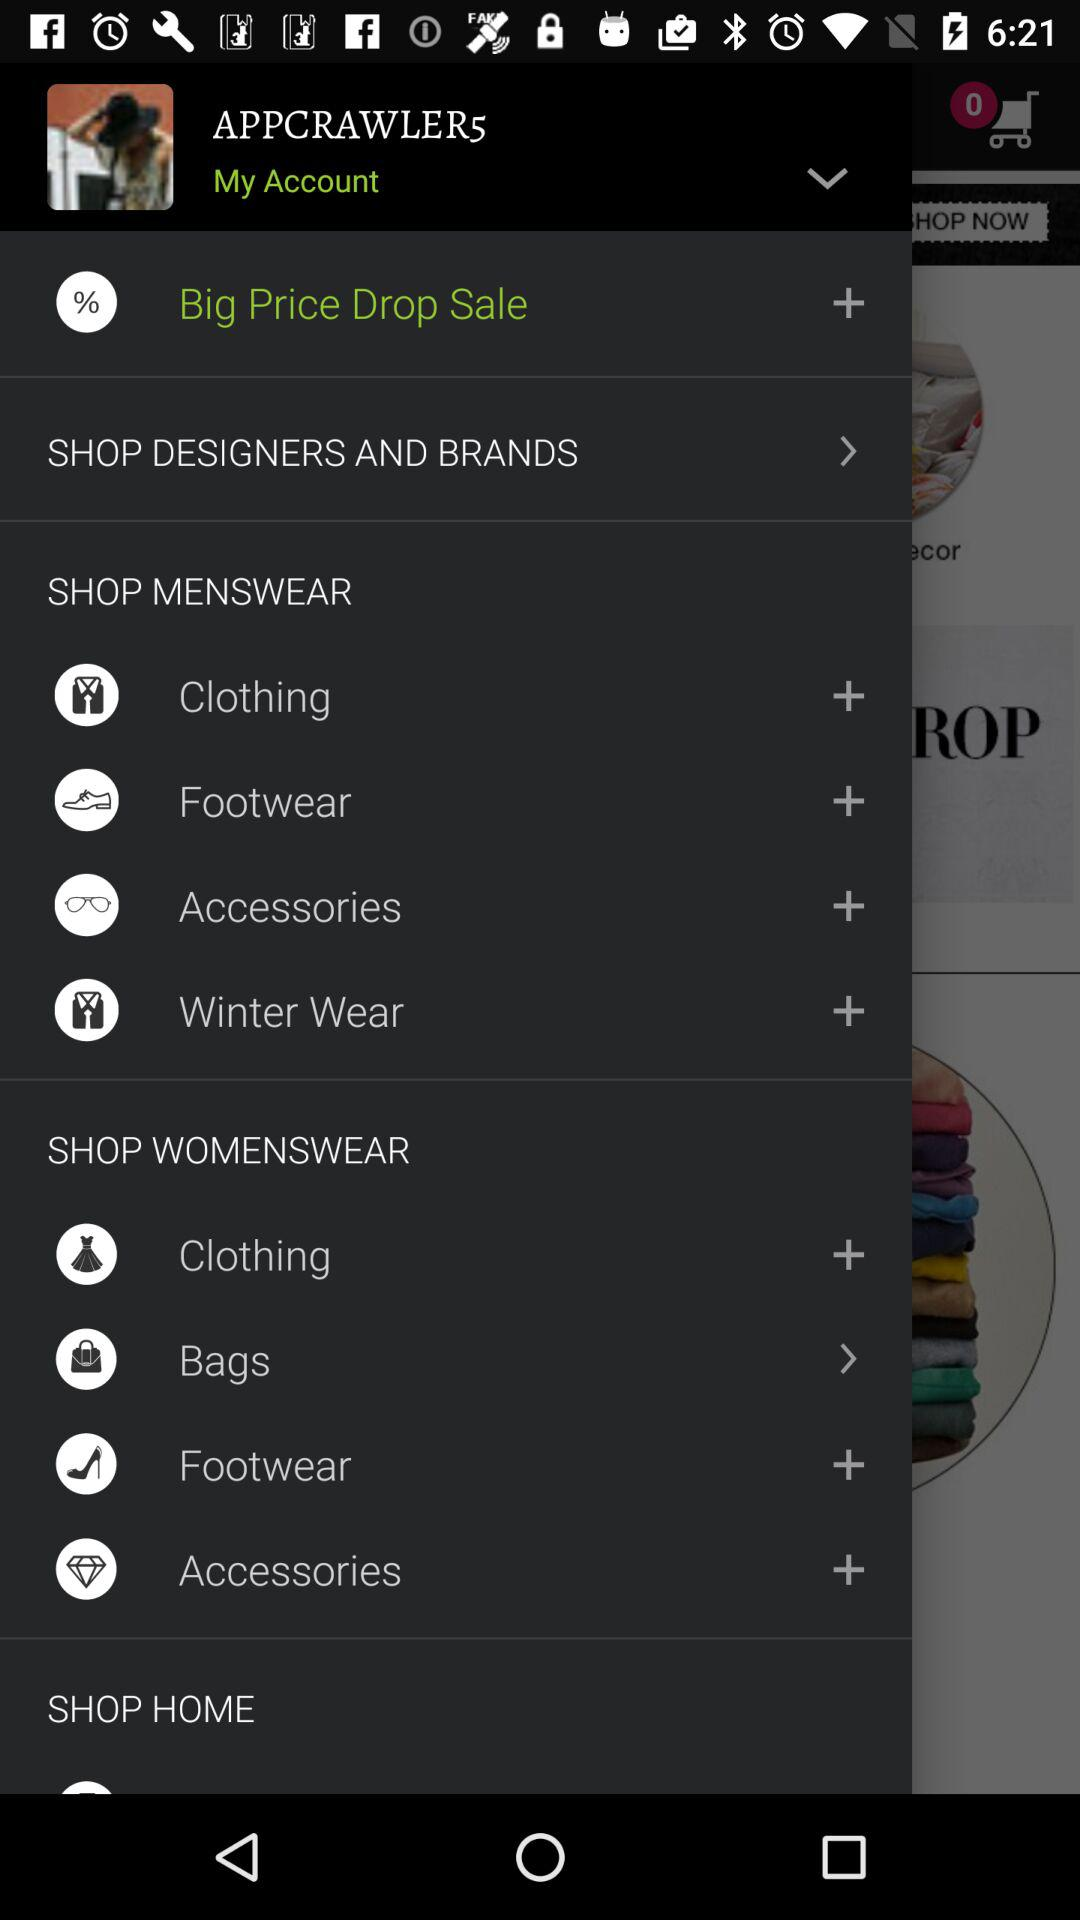What is the name of the user? The name of the user is APPCRAWLER5. 